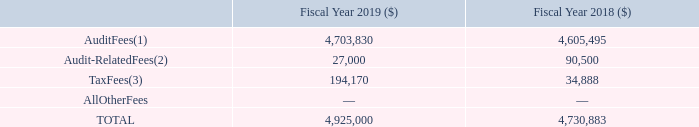Fees Billed by Ernst & Young LLP
The table below shows the fees billed by EY for audit and other services provided to the Company in fiscal years 2019 and 2018.
Figure 48. FY2019/2018 Fees Billed by Ernst & Young LLP
(1) Audit Fees represent fees for professional services provided in connection with the audits of annual financial statements. Audit Fees also include reviews of quarterly financial statements, audit services related to other statutory or regulatory filings or engagements, and fees related to EY’s audit of the effectiveness of the Company’s internal control over financial reporting pursuant to section 404 of the Sarbanes-Oxley Act.
(2) Audit-Related Fees represent fees for assurance and related services that are reasonably related to the audit or review of the Company’s financial statements and are not reported above under “Audit Fees”. These fees principally include due diligence and accounting consultation fees in connection with our acquisition of Coventor, Inc. in 2018 and an information systems audit in 2019.
(3) Tax Fees represent fees for professional services for tax planning, tax compliance and review services related to foreign tax compliance and assistance with tax audits and appeals.
The audit committee reviewed summaries of the services provided by EY and the related fees during fiscal year 2019 and has determined that the provision of non-audit services was compatible with maintaining the independence of EY as the Company’s independent registered public accounting firm. The audit committee or its delegate approved 100% of the services and related fee amounts for services provided by EY during fiscal year 2019.
What do the the audit fees represent? Fees for professional services provided in connection with the audits of annual financial statements. What do tax fees represent? Fees for professional services for tax planning, tax compliance and review services related to foreign tax compliance and assistance with tax audits and appeals. What do the audit-related fees represent? Fees for assurance and related services that are reasonably related to the audit or review of the company’s financial statements and are not reported above under “audit fees”. What is the percentage change in the audit fees from 2018 to 2019?
Answer scale should be: percent. (4,703,830-4,605,495)/4,605,495
Answer: 2.14. What is the percentage change in the audit-related fees from 2018 to 2019?
Answer scale should be: percent. (27,000-90,500)/90,500
Answer: -70.17. What is the percentage change in the total fees from 2018 to 2019?
Answer scale should be: percent. (4,925,000-4,730,883)/4,730,883
Answer: 4.1. 